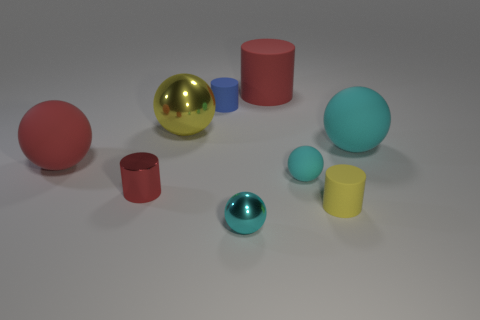What number of other things are there of the same color as the large cylinder?
Offer a very short reply. 2. What number of big matte cylinders are there?
Offer a very short reply. 1. What is the material of the cyan sphere behind the red rubber thing that is in front of the metal thing behind the big cyan rubber object?
Ensure brevity in your answer.  Rubber. There is a metal sphere behind the shiny cylinder; what number of small yellow things are in front of it?
Offer a very short reply. 1. What is the color of the small matte thing that is the same shape as the yellow metallic object?
Your answer should be very brief. Cyan. Is the yellow sphere made of the same material as the large red cylinder?
Offer a terse response. No. How many cubes are small red objects or small blue matte things?
Offer a terse response. 0. There is a red cylinder in front of the large red rubber cylinder on the left side of the sphere right of the tiny yellow thing; how big is it?
Give a very brief answer. Small. What is the size of the yellow metal thing that is the same shape as the small cyan rubber thing?
Your answer should be very brief. Large. How many tiny metallic balls are in front of the yellow cylinder?
Your answer should be compact. 1. 